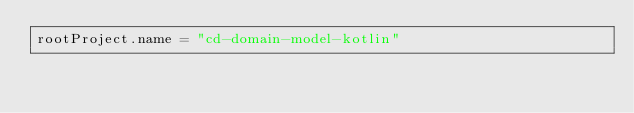Convert code to text. <code><loc_0><loc_0><loc_500><loc_500><_Kotlin_>rootProject.name = "cd-domain-model-kotlin"
</code> 